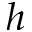<formula> <loc_0><loc_0><loc_500><loc_500>h</formula> 